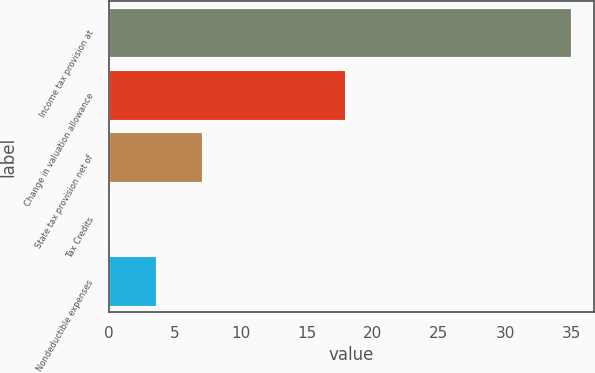<chart> <loc_0><loc_0><loc_500><loc_500><bar_chart><fcel>Income tax provision at<fcel>Change in valuation allowance<fcel>State tax provision net of<fcel>Tax Credits<fcel>Nondeductible expenses<nl><fcel>35<fcel>17.9<fcel>7.08<fcel>0.1<fcel>3.59<nl></chart> 